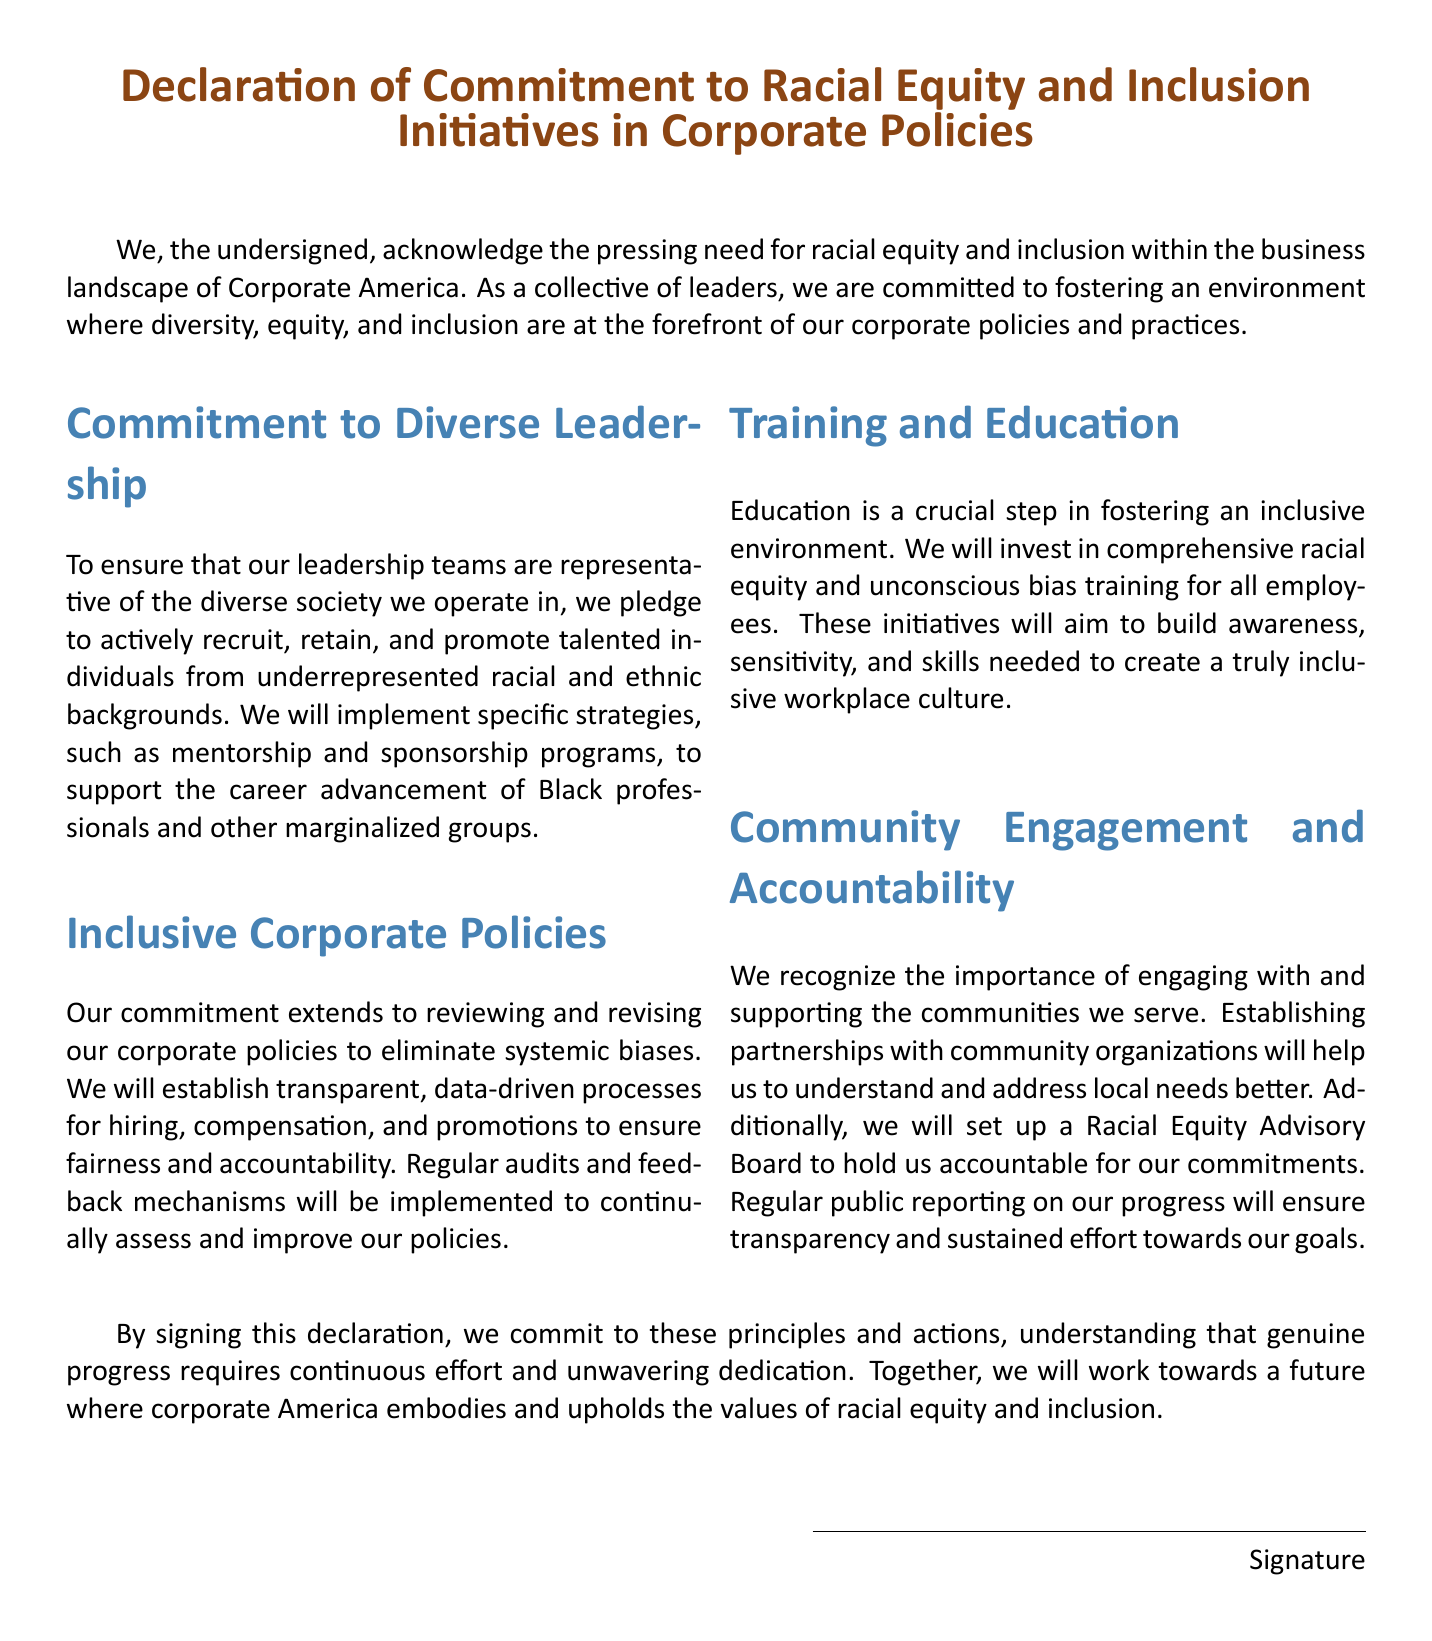What is the title of the document? The title of the document is explicitly stated at the top and is in a larger font size, indicating its importance.
Answer: Declaration of Commitment to Racial Equity and Inclusion Initiatives in Corporate Policies Who are the signatories? The document mentions "the undersigned," referring to the leaders who have signed it, but does not list specific names.
Answer: Undersigned What is the primary focus of this declaration? The declaration emphasizes the need for racial equity and inclusion, particularly in corporate policies and practices.
Answer: Racial equity and inclusion What type of training will be provided? The document specifies certain training initiatives aimed at promoting awareness and skills necessary for inclusivity.
Answer: Racial equity and unconscious bias training What will be established to hold the organization accountable? The declaration outlines the creation of a specific board as a means to ensure accountability for their commitments.
Answer: Racial Equity Advisory Board What is one strategy mentioned for career advancement? The document highlights initiatives to foster growth for underrepresented groups within the organization.
Answer: Mentorship and sponsorship programs How will the company assess its policies? The document states that audits and feedback mechanisms should be put in place to evaluate the effectiveness of their policies regularly.
Answer: Regular audits and feedback mechanisms What is one goal of community engagement? The document mentions the importance of understanding and addressing the needs of the communities they serve.
Answer: Understanding and addressing local needs What commitment does the document express regarding leadership teams? The document emphasizes the need for leadership teams to reflect the diversity within society.
Answer: Representative of the diverse society 